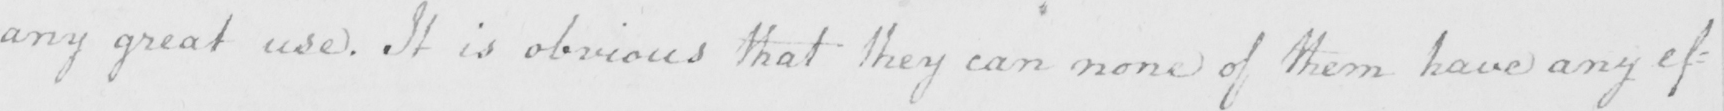Can you tell me what this handwritten text says? any great use . It is obvious that they can none of them have any ef= 